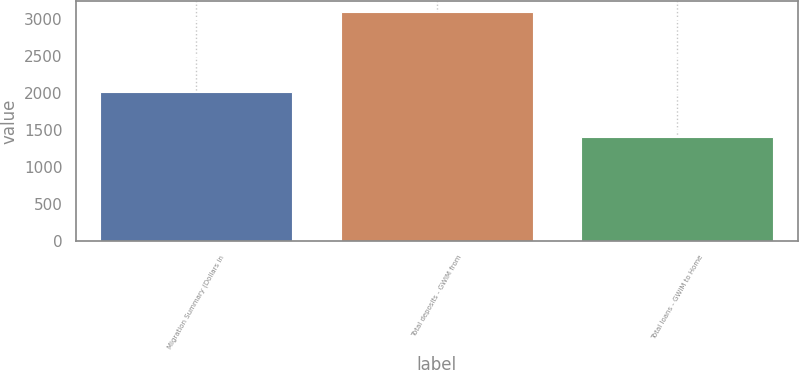Convert chart. <chart><loc_0><loc_0><loc_500><loc_500><bar_chart><fcel>Migration Summary (Dollars in<fcel>Total deposits - GWIM from<fcel>Total loans - GWIM to Home<nl><fcel>2010<fcel>3086<fcel>1405<nl></chart> 